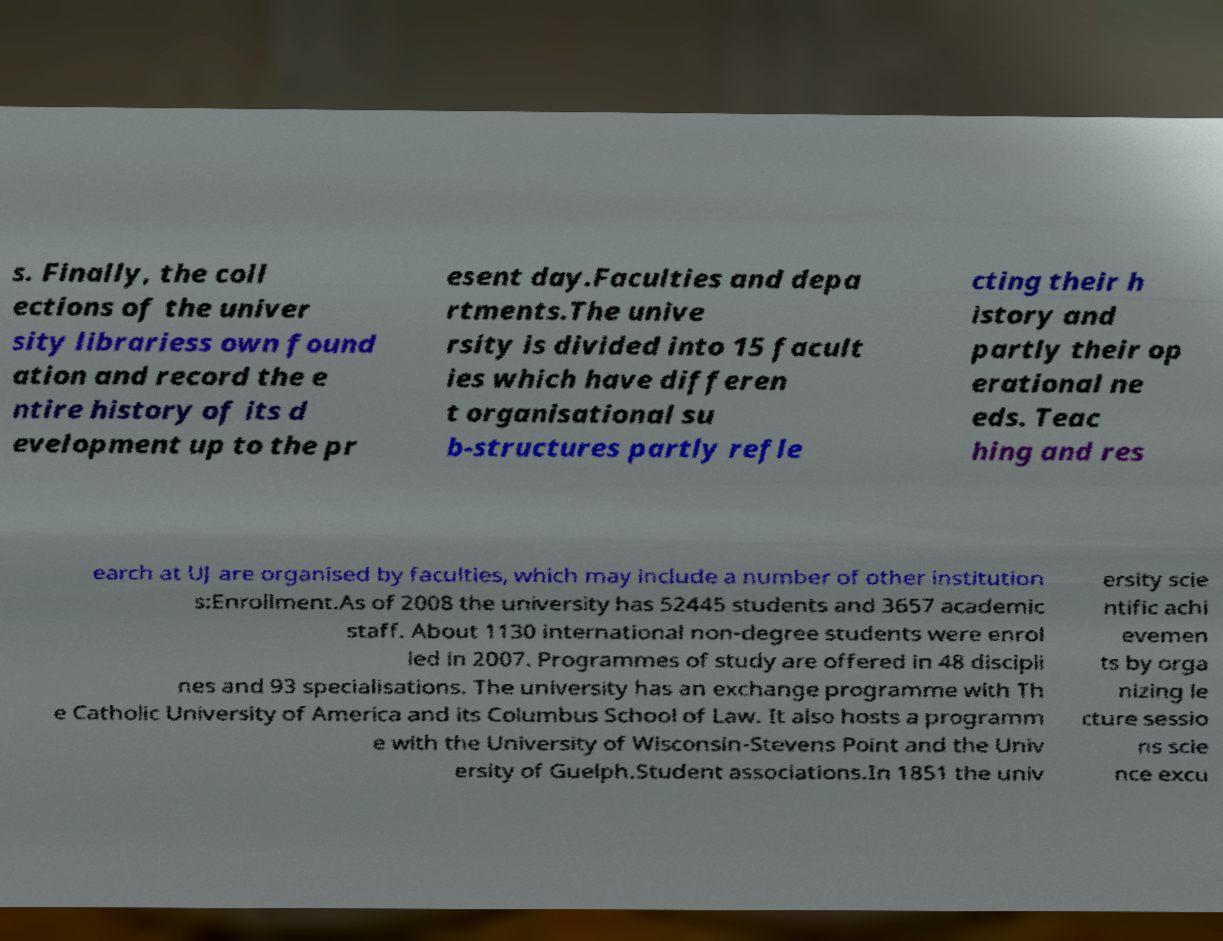There's text embedded in this image that I need extracted. Can you transcribe it verbatim? s. Finally, the coll ections of the univer sity librariess own found ation and record the e ntire history of its d evelopment up to the pr esent day.Faculties and depa rtments.The unive rsity is divided into 15 facult ies which have differen t organisational su b-structures partly refle cting their h istory and partly their op erational ne eds. Teac hing and res earch at UJ are organised by faculties, which may include a number of other institution s:Enrollment.As of 2008 the university has 52445 students and 3657 academic staff. About 1130 international non-degree students were enrol led in 2007. Programmes of study are offered in 48 discipli nes and 93 specialisations. The university has an exchange programme with Th e Catholic University of America and its Columbus School of Law. It also hosts a programm e with the University of Wisconsin-Stevens Point and the Univ ersity of Guelph.Student associations.In 1851 the univ ersity scie ntific achi evemen ts by orga nizing le cture sessio ns scie nce excu 